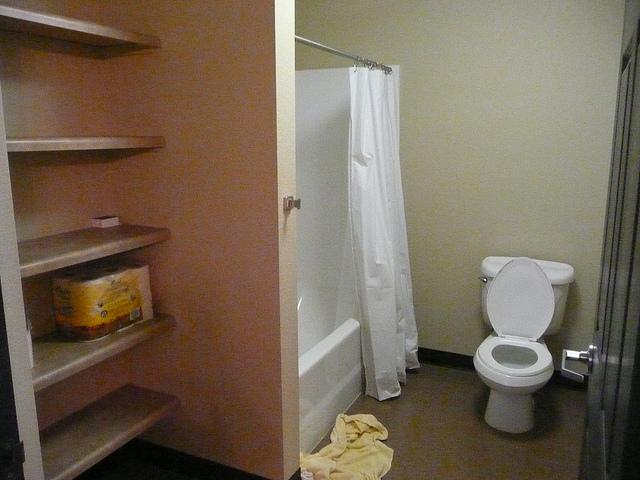Is this bathroom clean?
Write a very short answer. Yes. What is this room?
Keep it brief. Bathroom. Is their natural light in this room?
Be succinct. No. What is the color of the shower curtain?
Keep it brief. White. 